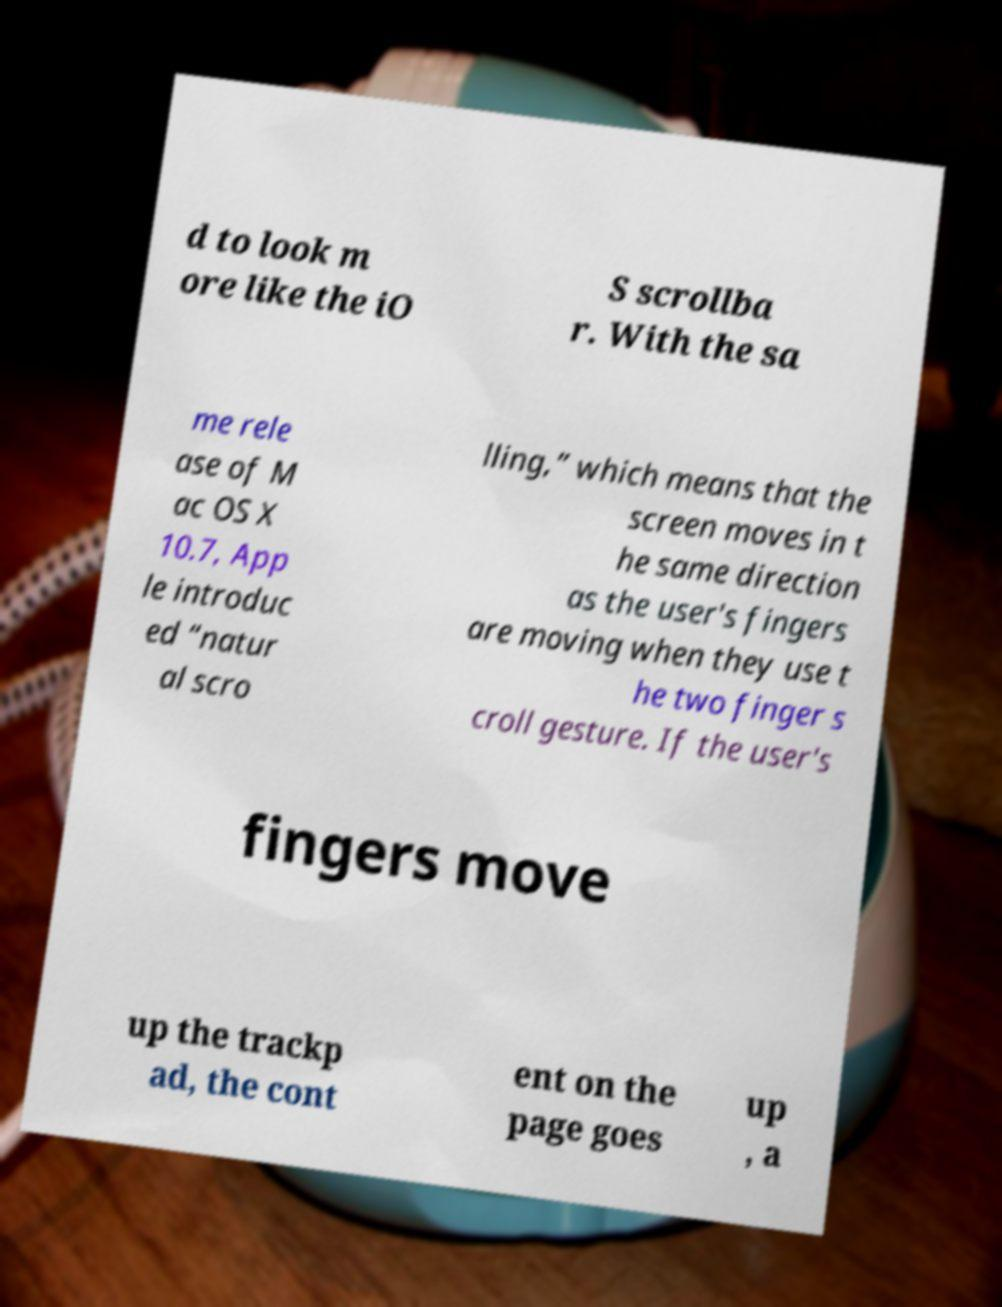Can you read and provide the text displayed in the image?This photo seems to have some interesting text. Can you extract and type it out for me? d to look m ore like the iO S scrollba r. With the sa me rele ase of M ac OS X 10.7, App le introduc ed “natur al scro lling,” which means that the screen moves in t he same direction as the user's fingers are moving when they use t he two finger s croll gesture. If the user's fingers move up the trackp ad, the cont ent on the page goes up , a 